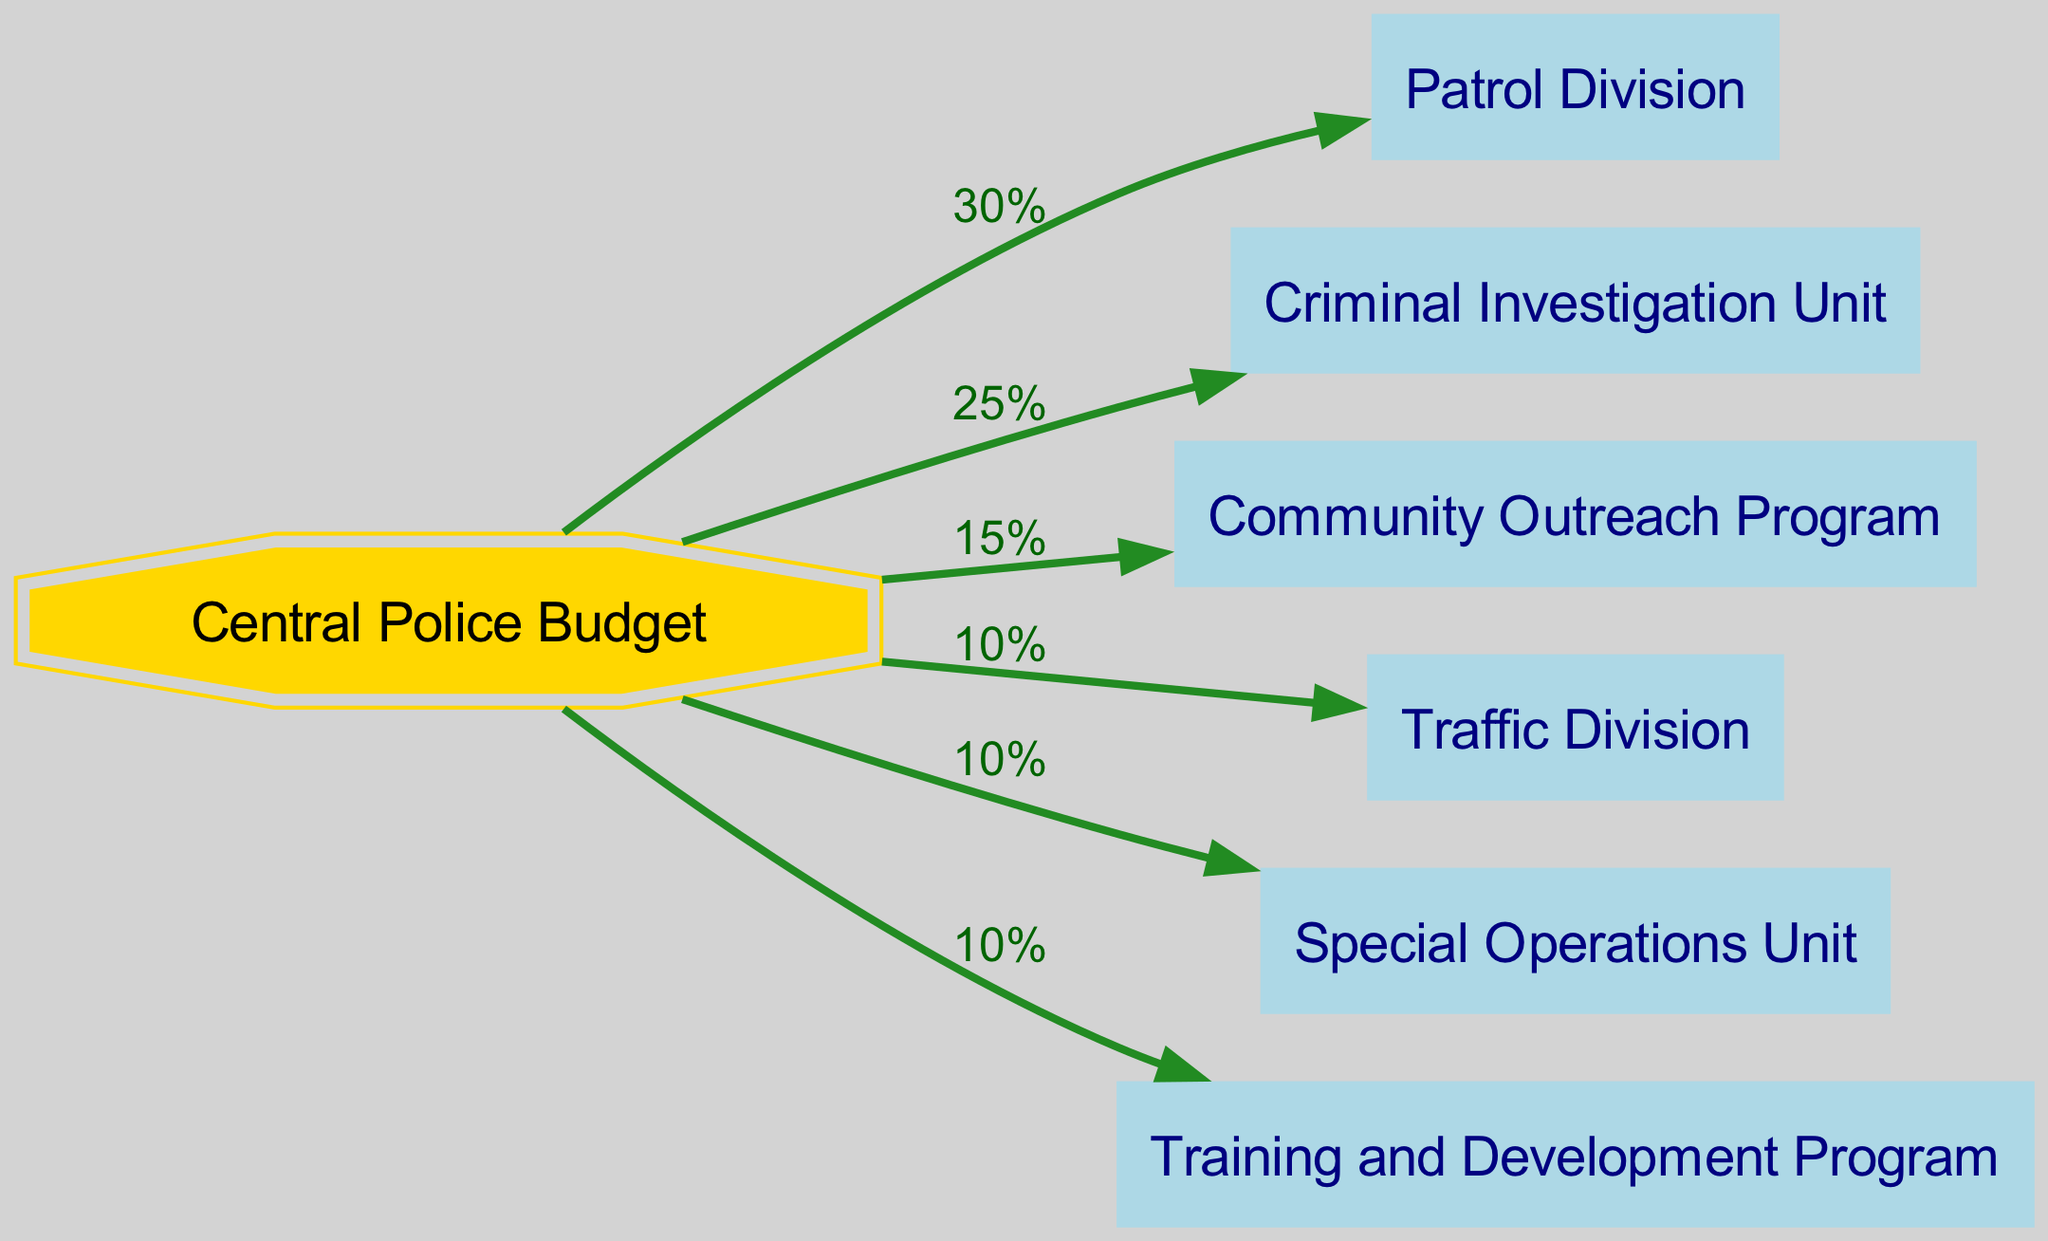What percentage of the Central Police Budget is allocated to the Patrol Division? The diagram shows an edge from the Central Police Budget to the Patrol Division labeled "30%", indicating that 30% of the budget is allocated to this division.
Answer: 30% How many total units and programs are funded by the Central Police Budget? The diagram lists six units and programs connected directly to the Central Police Budget: Patrol Division, Criminal Investigation Unit, Community Outreach Program, Traffic Division, Special Operations Unit, and Training and Development Program. Therefore, the total count is six.
Answer: 6 Which unit has the smallest percentage allocation from the Central Police Budget? By examining all connections from the Central Police Budget, the Traffic Division and Special Operations Unit are each allocated 10%, which is the smallest allocation compared to others.
Answer: Traffic Division and Special Operations Unit How much of the budget is allocated to community-related initiatives? The Community Outreach Program is allocated 15% and the Patrol Division can be considered community-related with its 30% allocation. Adding these together yields a total of 45%.
Answer: 45% Which two units are allocated the highest percentages, and what are those percentages? The Patrol Division receives the highest allocation at 30%, followed by the Criminal Investigation Unit at 25%. Thus, the top two units are Patrol Division with 30% and Criminal Investigation Unit with 25%.
Answer: Patrol Division 30%, Criminal Investigation Unit 25% What is the total percentage allocated to training and operational activities combined? The Training and Development Program receives 10% of the budget, and the Special Operations Unit also receives an allocation of 10%. Adding these percentages together gives a total allocation of 20%.
Answer: 20% Which edge represents the flow of the largest amount of budget from the Central Police Budget? The edge from the Central Police Budget to the Patrol Division is labeled "30%", indicating that it represents the flow of the largest amount of budget compared to other edges.
Answer: Patrol Division What is the total percentage of the budget that goes toward specialized units (Criminal Investigation and Special Operations)? The Criminal Investigation Unit has an allocation of 25%, and the Special Operations Unit has 10%. Adding these allocations results in a total of 35%.
Answer: 35% 